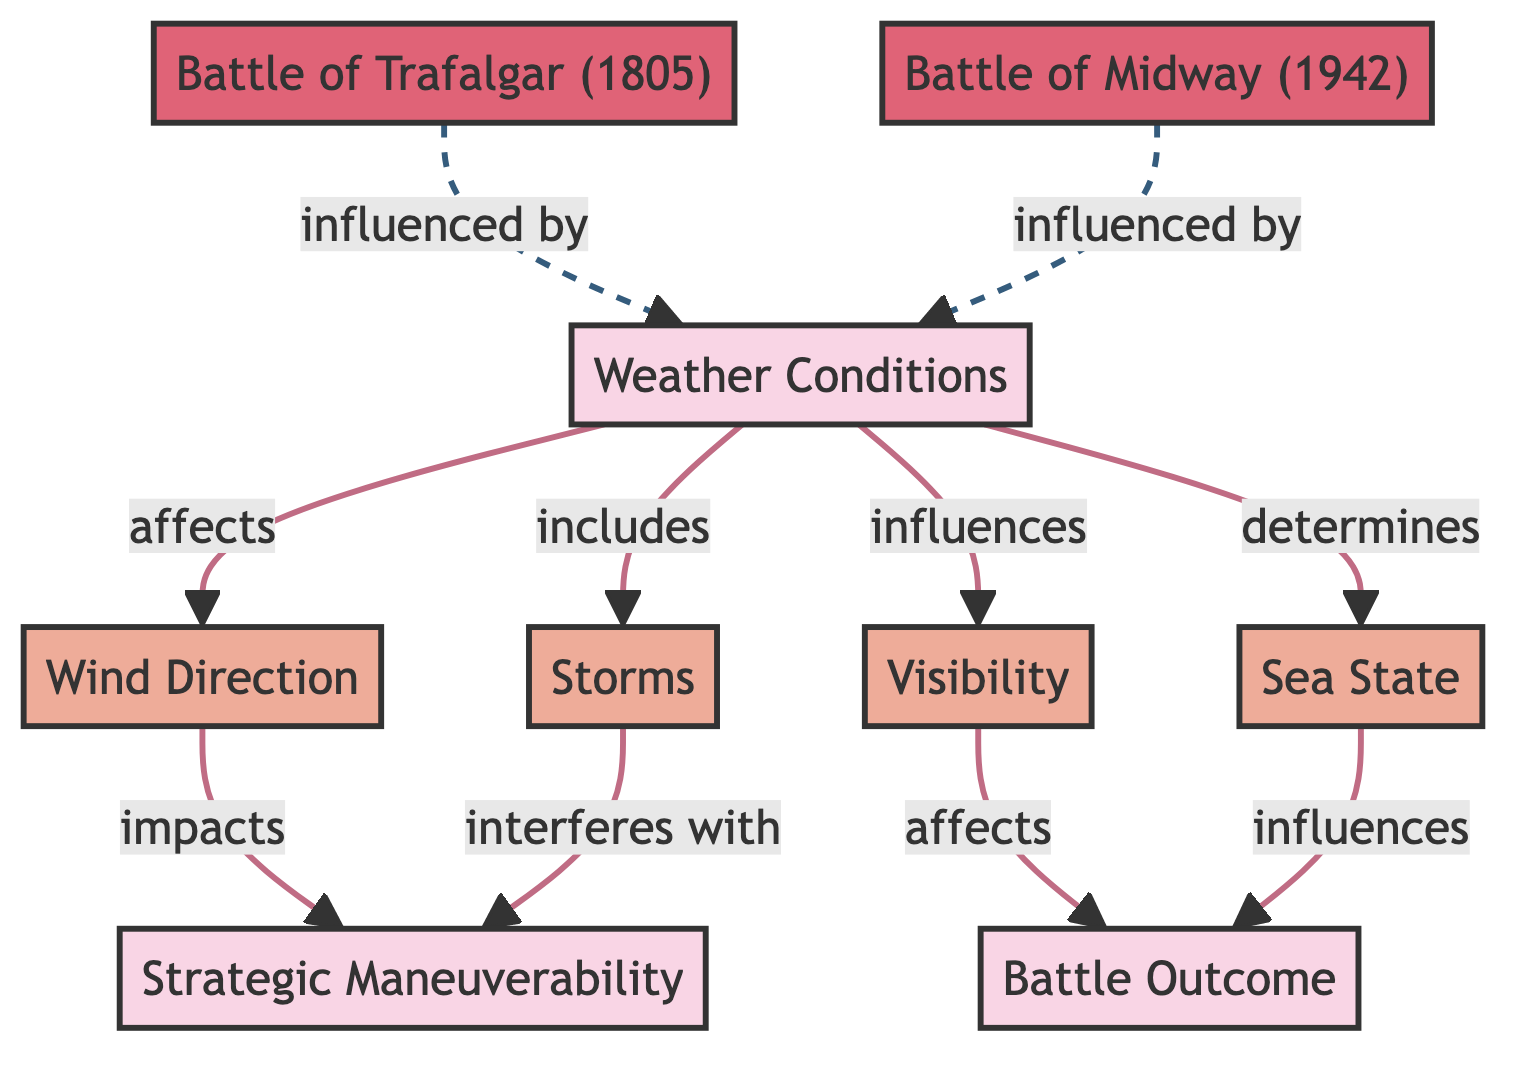What are the main factors related to weather conditions in the diagram? The diagram lists four main factors: Wind Direction, Storms, Visibility, and Sea State, which are all categorized under Weather Conditions.
Answer: Wind Direction, Storms, Visibility, Sea State How many historical events are mentioned in the diagram? There are two historical events referenced in the diagram: the Battle of Trafalgar (1805) and the Battle of Midway (1942).
Answer: 2 Which historical event is influenced by Storms? The diagram indicates that Storms interfere with Strategic Maneuverability, but it doesn't directly state that Storms influence any specific historical event. However, since both the Battle of Trafalgar and the Battle of Midway are influenced by Weather Conditions, they could be indirectly suggested to be influenced by Storms.
Answer: All historical events What does Wind Direction impact according to the diagram? The diagram shows that Wind Direction impacts Strategic Maneuverability, indicating a relationship between them.
Answer: Strategic Maneuverability What type of relationship does Visibility have with Battle Outcome? Visibility affects Battle Outcome, which implies a direct impact or relationship, as shown in the diagram.
Answer: Affects Based on the diagram, how does Sea State influence the Battle Outcome? Sea State influences Battle Outcome according to the information presented in the diagram. This indicates that the state of the sea can affect the results of a battle, potentially through factors like maneuverability or visibility during combat.
Answer: Influences What are the two categories mentioned in the diagram and their significance? The two categories are Weather Conditions, which encompass various weather factors, and Battle Outcome, which signifies the results of the battles analyzed. This reflects the cause-effect relationship between these categories in the context of naval battles.
Answer: Weather Conditions, Battle Outcome How do Storms relate to Strategic Maneuverability? The diagram illustrates that Storms interfere with Strategic Maneuverability, indicating that adverse weather can hinder effective movements in naval strategy during battles.
Answer: Interferes with What style is used for the relationship links in the diagram? The default link styles are described to have a stroke width of 2 pixels, filled with none, and a color specified as #c06c84, indicating a standard styling for the relationships in the diagram.
Answer: Stroke width: 2 pixels, fill: none, color: #c06c84 